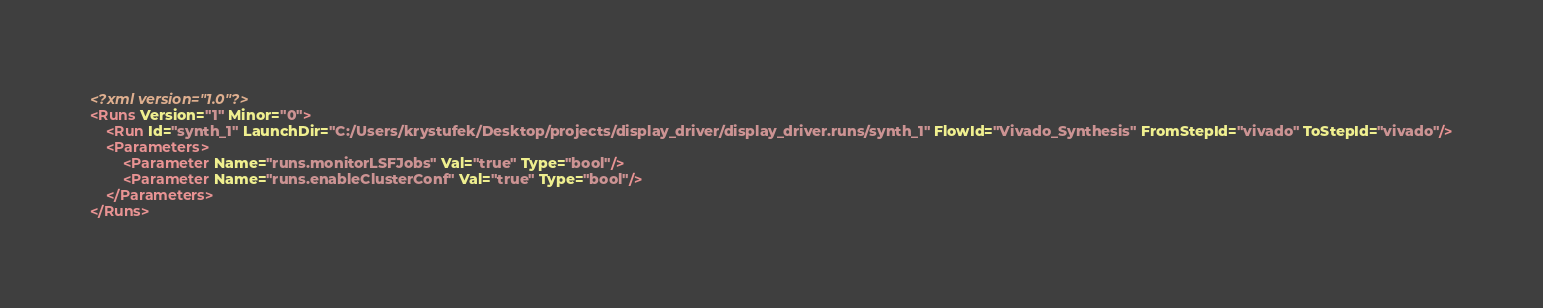<code> <loc_0><loc_0><loc_500><loc_500><_XML_><?xml version="1.0"?>
<Runs Version="1" Minor="0">
	<Run Id="synth_1" LaunchDir="C:/Users/krystufek/Desktop/projects/display_driver/display_driver.runs/synth_1" FlowId="Vivado_Synthesis" FromStepId="vivado" ToStepId="vivado"/>
	<Parameters>
		<Parameter Name="runs.monitorLSFJobs" Val="true" Type="bool"/>
		<Parameter Name="runs.enableClusterConf" Val="true" Type="bool"/>
	</Parameters>
</Runs>

</code> 